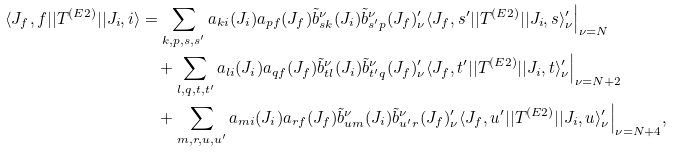<formula> <loc_0><loc_0><loc_500><loc_500>\langle J _ { f } , f | | T ^ { ( E 2 ) } | | J _ { i } , i \rangle & = \sum _ { k , p , s , s ^ { \prime } } a _ { k i } ( J _ { i } ) a _ { p f } ( J _ { f } ) \tilde { b } ^ { \nu } _ { s k } ( J _ { i } ) \tilde { b } ^ { \nu } _ { s ^ { \prime } p } ( J _ { f } ) _ { \nu } ^ { \prime } \langle J _ { f } , s ^ { \prime } | | T ^ { ( E 2 ) } | | J _ { i } , s \rangle ^ { \prime } _ { \nu } \Big | _ { \nu = N } \\ & \quad + \sum _ { l , q , t , t ^ { \prime } } a _ { l i } ( J _ { i } ) a _ { q f } ( J _ { f } ) \tilde { b } ^ { \nu } _ { t l } ( J _ { i } ) \tilde { b } ^ { \nu } _ { t ^ { \prime } q } ( J _ { f } ) ^ { \prime } _ { \nu } \langle J _ { f } , t ^ { \prime } | | T ^ { ( E 2 ) } | | J _ { i } , t \rangle ^ { \prime } _ { \nu } \Big | _ { \nu = N + 2 } \\ & \quad + \sum _ { m , r , u , u ^ { \prime } } a _ { m i } ( J _ { i } ) a _ { r f } ( J _ { f } ) \tilde { b } ^ { \nu } _ { u m } ( J _ { i } ) \tilde { b } ^ { \nu } _ { u ^ { \prime } r } ( J _ { f } ) ^ { \prime } _ { \nu } \langle J _ { f } , u ^ { \prime } | | T ^ { ( E 2 ) } | | J _ { i } , u \rangle ^ { \prime } _ { \nu } \Big | _ { \nu = N + 4 } ,</formula> 